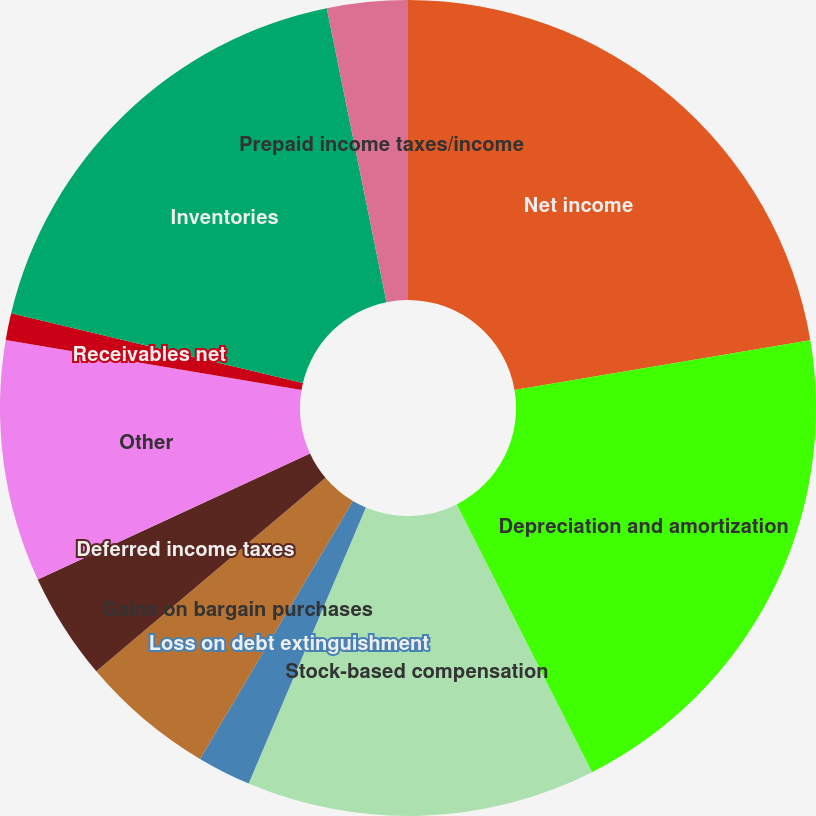Convert chart to OTSL. <chart><loc_0><loc_0><loc_500><loc_500><pie_chart><fcel>Net income<fcel>Depreciation and amortization<fcel>Stock-based compensation<fcel>Loss on debt extinguishment<fcel>Gains on bargain purchases<fcel>Deferred income taxes<fcel>Other<fcel>Receivables net<fcel>Inventories<fcel>Prepaid income taxes/income<nl><fcel>22.34%<fcel>20.21%<fcel>13.83%<fcel>2.13%<fcel>5.32%<fcel>4.26%<fcel>9.57%<fcel>1.06%<fcel>18.08%<fcel>3.19%<nl></chart> 